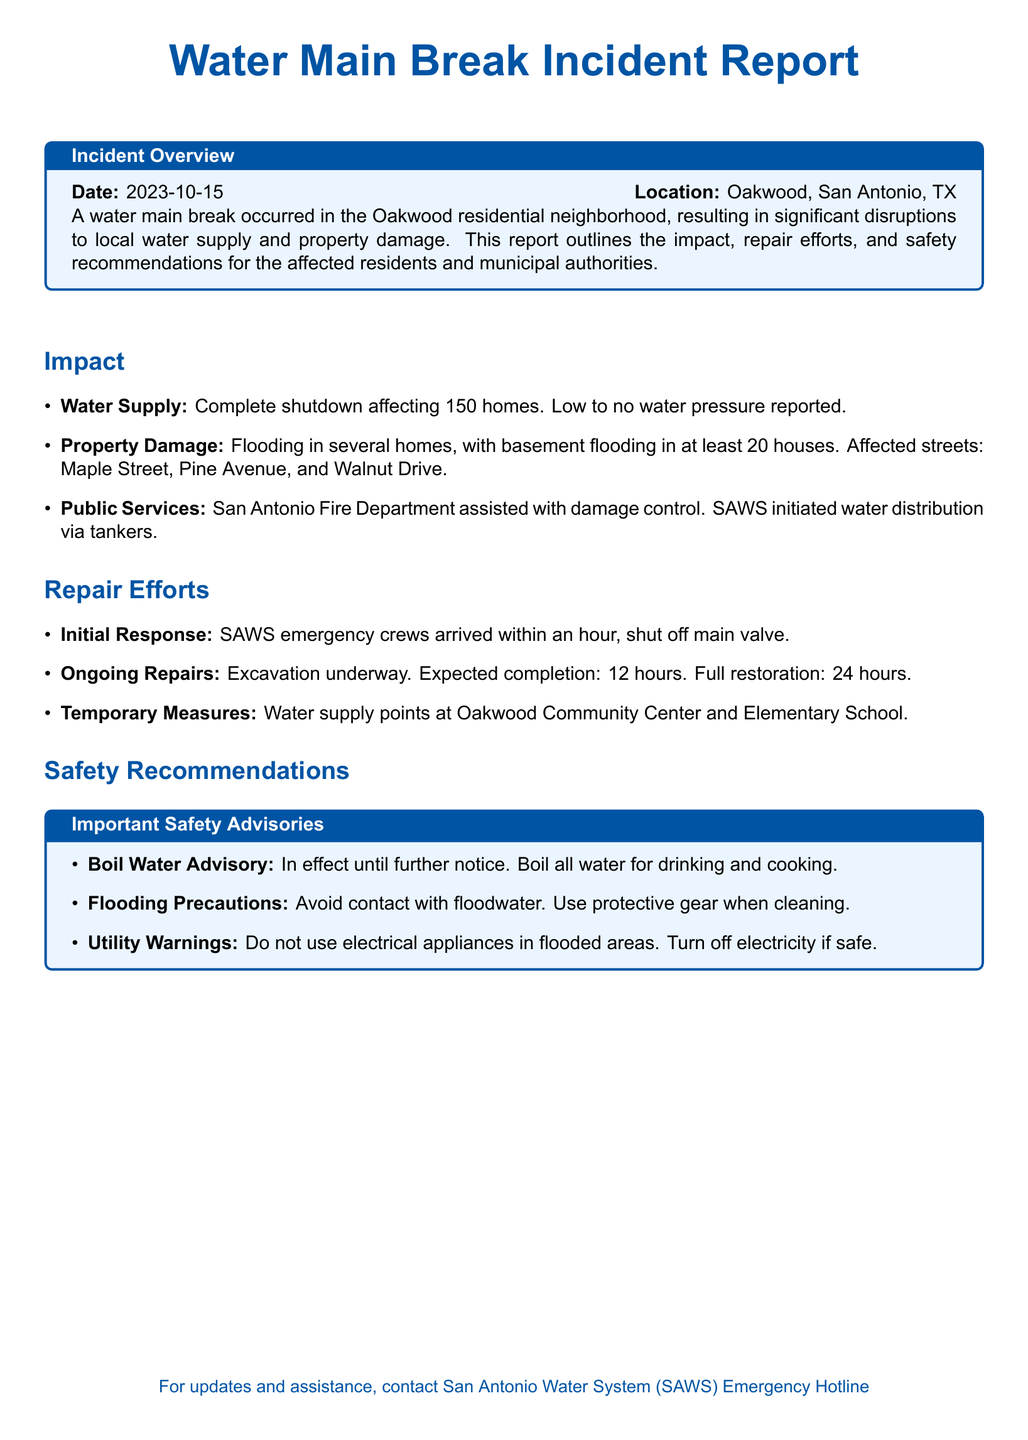what is the date of the incident? The date of the water main break incident is explicitly mentioned in the document as 2023-10-15.
Answer: 2023-10-15 how many homes were affected by the water supply shutdown? It is stated in the document that the complete shutdown affected 150 homes.
Answer: 150 homes what street had flooding along with Maple Street? The document lists Pine Avenue along with Maple Street as affected by flooding.
Answer: Pine Avenue how many houses experienced basement flooding? The report specifies that at least 20 houses experienced basement flooding due to the incident.
Answer: 20 houses what was the role of the San Antonio Fire Department? The document mentions that the San Antonio Fire Department assisted with damage control in the affected area.
Answer: Damage control what is the expected completion time for ongoing repairs? According to the document, the ongoing repairs are expected to be completed in 12 hours.
Answer: 12 hours is there a boil water advisory in effect? The document includes a section on safety recommendations indicating a boil water advisory is in effect.
Answer: Yes what is advised to avoid contact with? The safety recommendations explicitly advise to avoid contact with floodwater.
Answer: Floodwater what temporary measures were provided for water supply? The document states that temporary water supply points were set up at the Oakwood Community Center and Elementary School.
Answer: Oakwood Community Center and Elementary School 